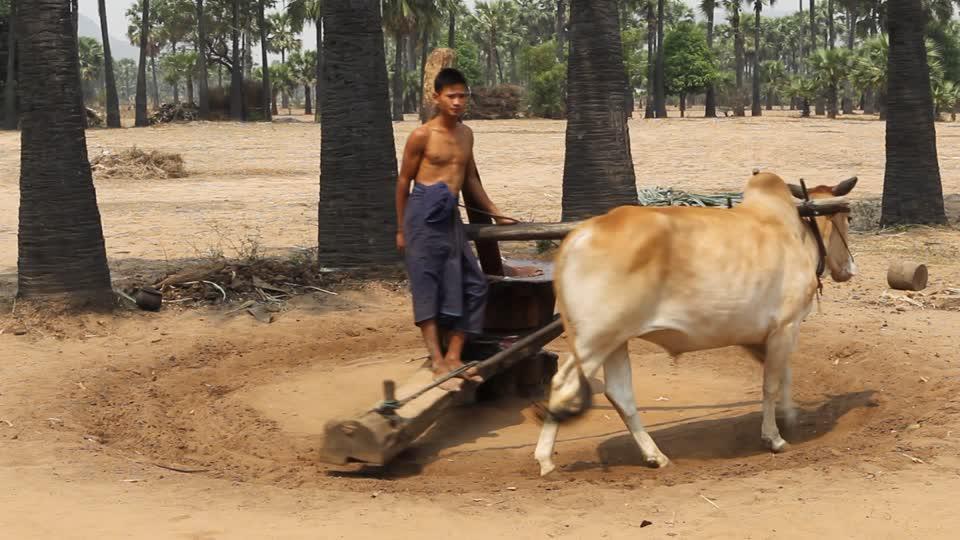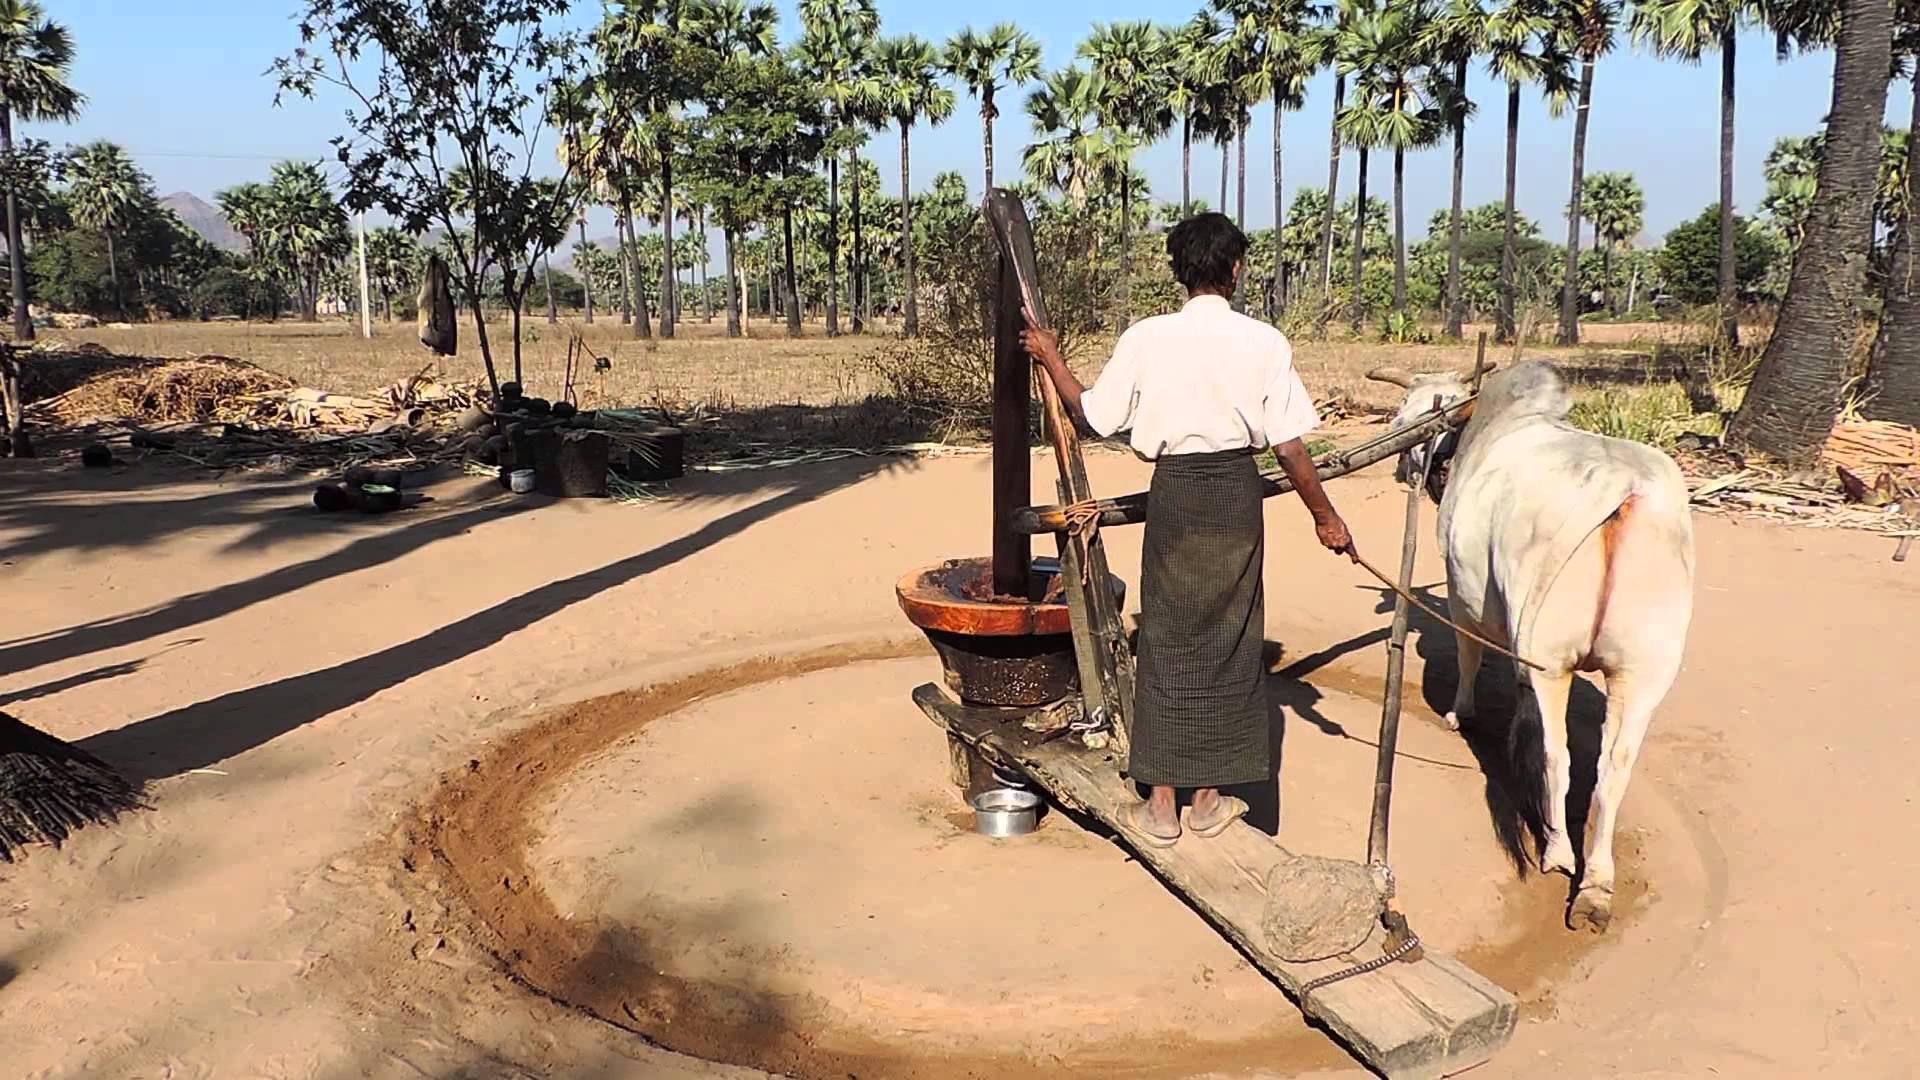The first image is the image on the left, the second image is the image on the right. Analyze the images presented: Is the assertion "There is a green bowl under a spout that comes out from the mill in the left image." valid? Answer yes or no. No. The first image is the image on the left, the second image is the image on the right. For the images shown, is this caption "The man attending the cow in one of the photos is shirtless." true? Answer yes or no. Yes. 